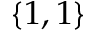<formula> <loc_0><loc_0><loc_500><loc_500>\{ 1 , 1 \}</formula> 